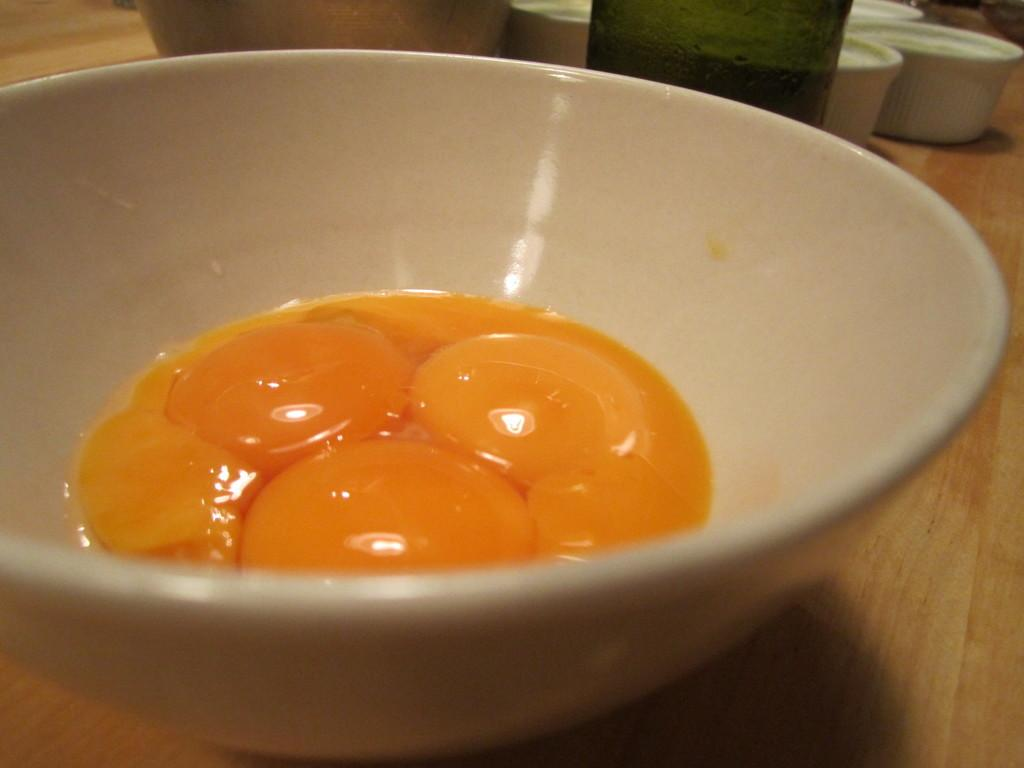What is in the bowl that is visible in the image? There is egg yolk in the bowl. What other items can be seen in the background of the image? There is a glass bottle and small cups beside the glass bottle in the background of the image. Where is the bowl located in the image? The bowl is on a table. What type of record is being played by the dad in the image? There is no dad or record present in the image. 